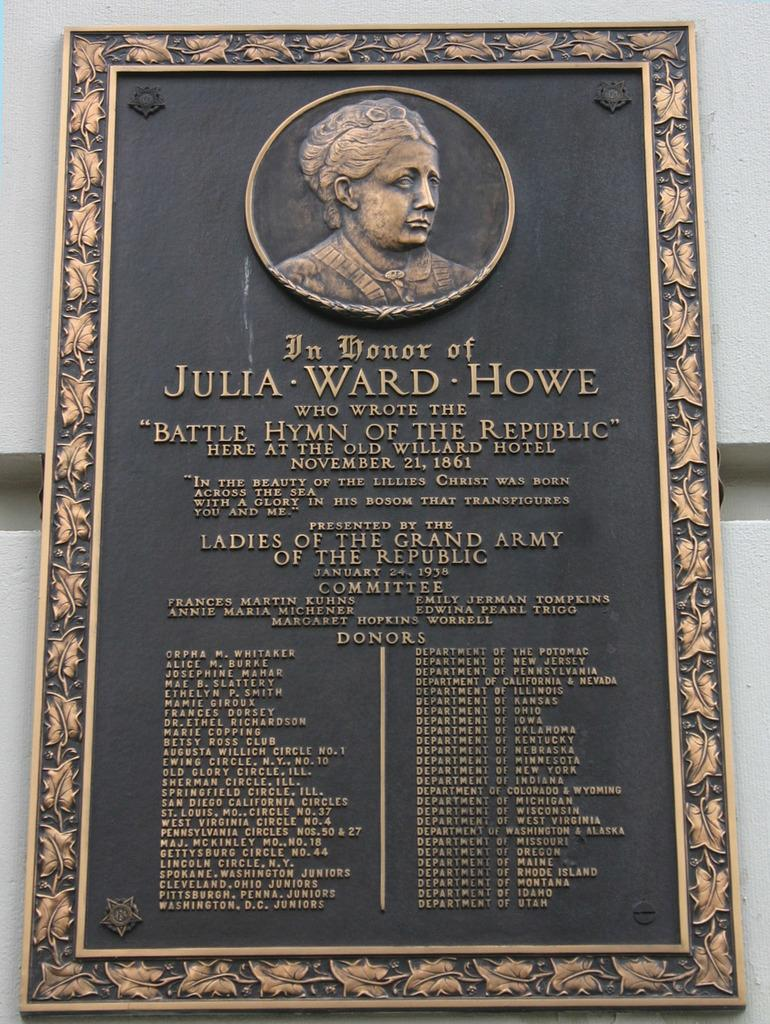<image>
Render a clear and concise summary of the photo. Plaque that shows a woman named Julia Ward Howe. 